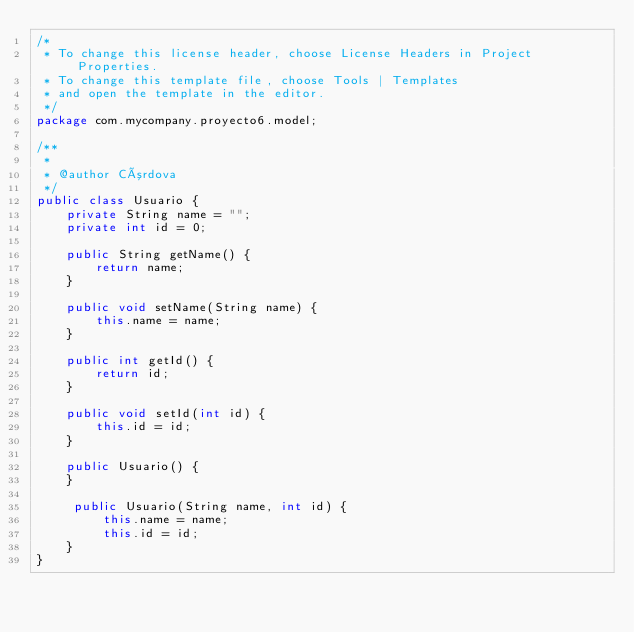Convert code to text. <code><loc_0><loc_0><loc_500><loc_500><_Java_>/*
 * To change this license header, choose License Headers in Project Properties.
 * To change this template file, choose Tools | Templates
 * and open the template in the editor.
 */
package com.mycompany.proyecto6.model;

/**
 *
 * @author Córdova
 */
public class Usuario {
    private String name = "";
    private int id = 0;

    public String getName() {
        return name;
    }

    public void setName(String name) {
        this.name = name;
    }

    public int getId() {
        return id;
    }

    public void setId(int id) {
        this.id = id;
    }

    public Usuario() {
    }
    
     public Usuario(String name, int id) {
         this.name = name;
         this.id = id;
    }
}
</code> 